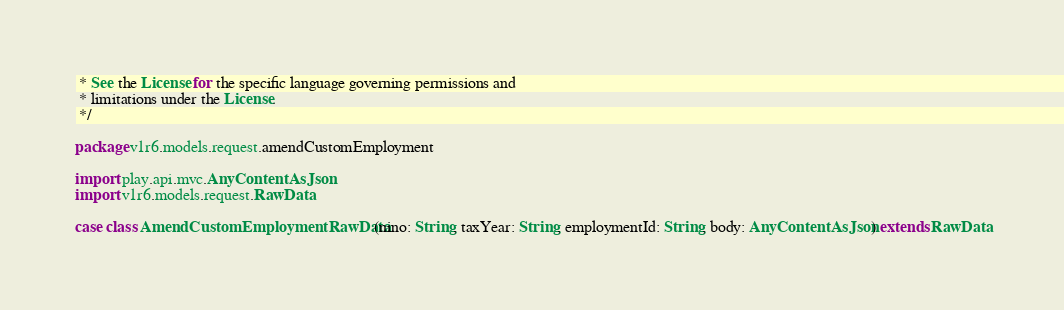<code> <loc_0><loc_0><loc_500><loc_500><_Scala_> * See the License for the specific language governing permissions and
 * limitations under the License.
 */

package v1r6.models.request.amendCustomEmployment

import play.api.mvc.AnyContentAsJson
import v1r6.models.request.RawData

case class AmendCustomEmploymentRawData(nino: String, taxYear: String, employmentId: String, body: AnyContentAsJson) extends RawData
</code> 